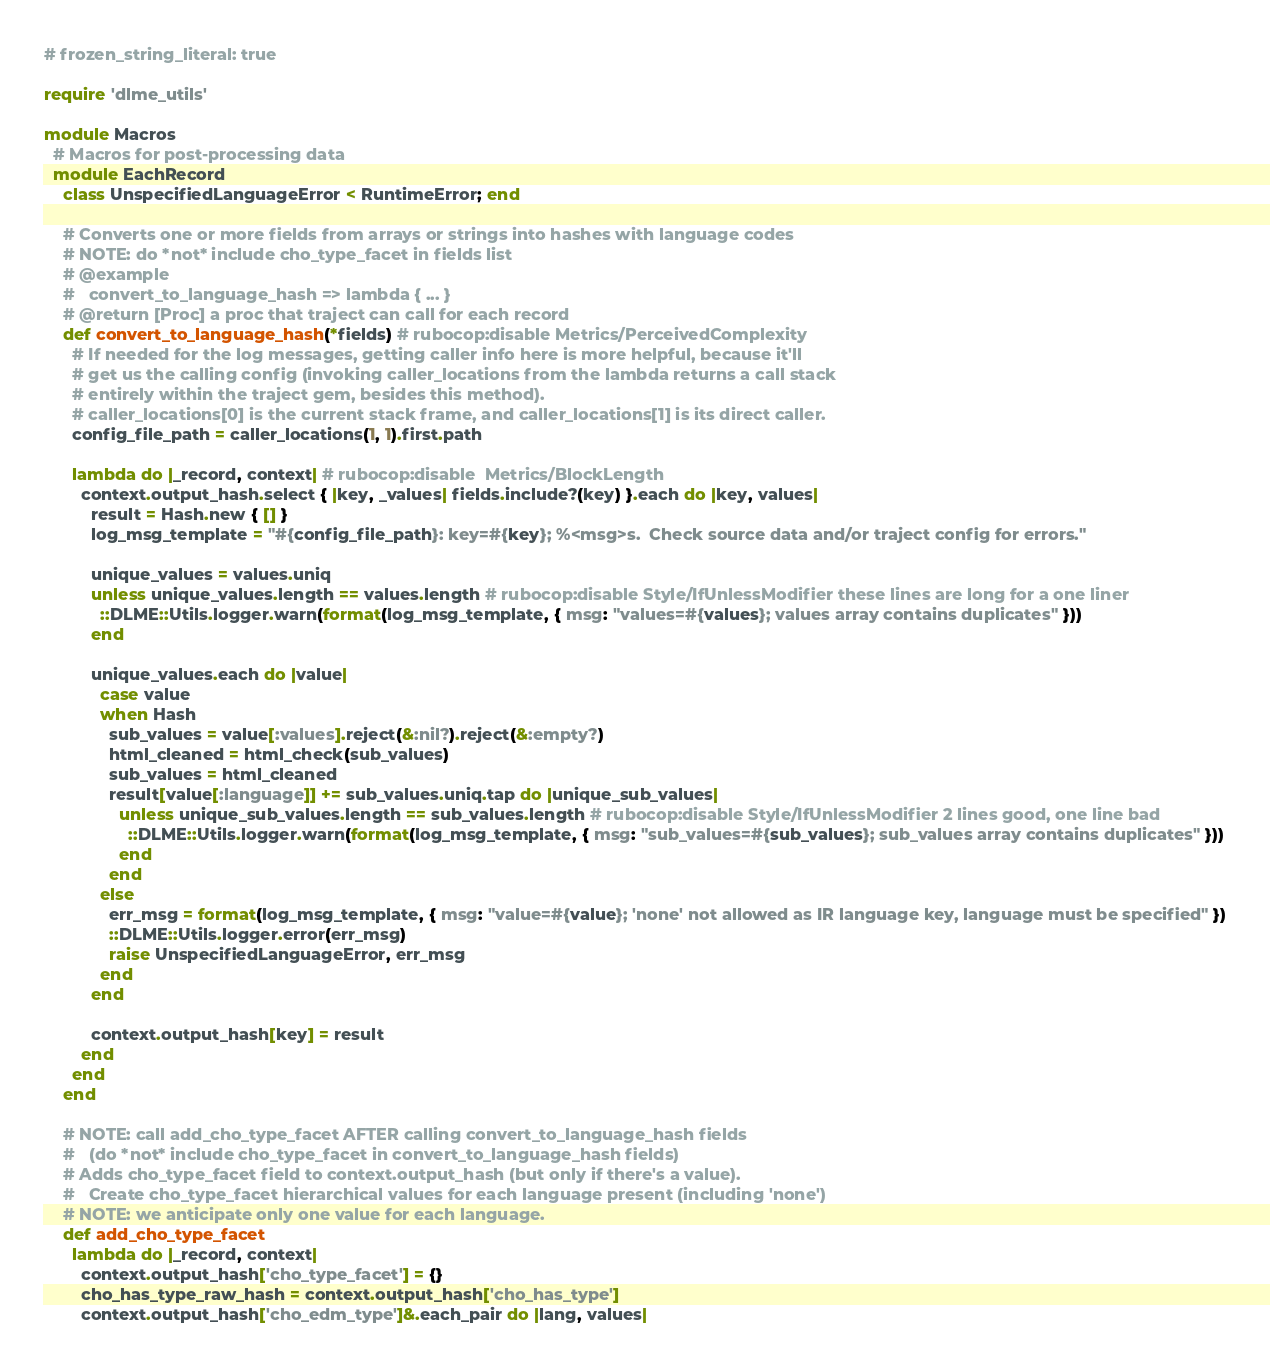<code> <loc_0><loc_0><loc_500><loc_500><_Ruby_># frozen_string_literal: true

require 'dlme_utils'

module Macros
  # Macros for post-processing data
  module EachRecord
    class UnspecifiedLanguageError < RuntimeError; end

    # Converts one or more fields from arrays or strings into hashes with language codes
    # NOTE: do *not* include cho_type_facet in fields list
    # @example
    #   convert_to_language_hash => lambda { ... }
    # @return [Proc] a proc that traject can call for each record
    def convert_to_language_hash(*fields) # rubocop:disable Metrics/PerceivedComplexity
      # If needed for the log messages, getting caller info here is more helpful, because it'll
      # get us the calling config (invoking caller_locations from the lambda returns a call stack
      # entirely within the traject gem, besides this method).
      # caller_locations[0] is the current stack frame, and caller_locations[1] is its direct caller.
      config_file_path = caller_locations(1, 1).first.path

      lambda do |_record, context| # rubocop:disable  Metrics/BlockLength
        context.output_hash.select { |key, _values| fields.include?(key) }.each do |key, values|
          result = Hash.new { [] }
          log_msg_template = "#{config_file_path}: key=#{key}; %<msg>s.  Check source data and/or traject config for errors."

          unique_values = values.uniq
          unless unique_values.length == values.length # rubocop:disable Style/IfUnlessModifier these lines are long for a one liner
            ::DLME::Utils.logger.warn(format(log_msg_template, { msg: "values=#{values}; values array contains duplicates" }))
          end

          unique_values.each do |value|
            case value
            when Hash
              sub_values = value[:values].reject(&:nil?).reject(&:empty?)
              html_cleaned = html_check(sub_values)
              sub_values = html_cleaned
              result[value[:language]] += sub_values.uniq.tap do |unique_sub_values|
                unless unique_sub_values.length == sub_values.length # rubocop:disable Style/IfUnlessModifier 2 lines good, one line bad
                  ::DLME::Utils.logger.warn(format(log_msg_template, { msg: "sub_values=#{sub_values}; sub_values array contains duplicates" }))
                end
              end
            else
              err_msg = format(log_msg_template, { msg: "value=#{value}; 'none' not allowed as IR language key, language must be specified" })
              ::DLME::Utils.logger.error(err_msg)
              raise UnspecifiedLanguageError, err_msg
            end
          end

          context.output_hash[key] = result
        end
      end
    end

    # NOTE: call add_cho_type_facet AFTER calling convert_to_language_hash fields
    #   (do *not* include cho_type_facet in convert_to_language_hash fields)
    # Adds cho_type_facet field to context.output_hash (but only if there's a value).
    #   Create cho_type_facet hierarchical values for each language present (including 'none')
    # NOTE: we anticipate only one value for each language.
    def add_cho_type_facet
      lambda do |_record, context|
        context.output_hash['cho_type_facet'] = {}
        cho_has_type_raw_hash = context.output_hash['cho_has_type']
        context.output_hash['cho_edm_type']&.each_pair do |lang, values|</code> 